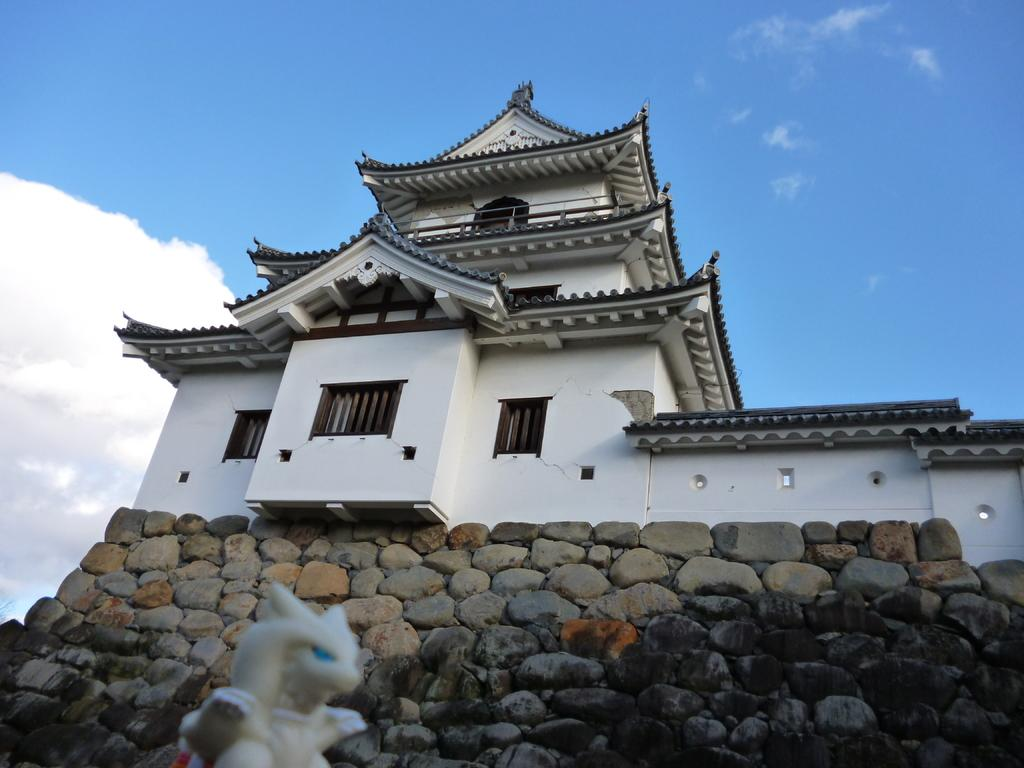What is the main structure in the center of the image? There is a building in the center of the image. What type of surface is visible at the bottom of the image? Cobblestones are visible at the bottom of the image. What can be seen at the bottom of the image besides the cobblestones? There is a sculpture at the bottom of the image. What is visible in the background of the image? The sky is visible in the background of the image. How many hydrants are visible in the image? There are no hydrants visible in the image. What type of tooth is present in the sculpture at the bottom of the image? There is no tooth present in the sculpture or any other part of the image. 